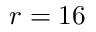Convert formula to latex. <formula><loc_0><loc_0><loc_500><loc_500>r = 1 6</formula> 